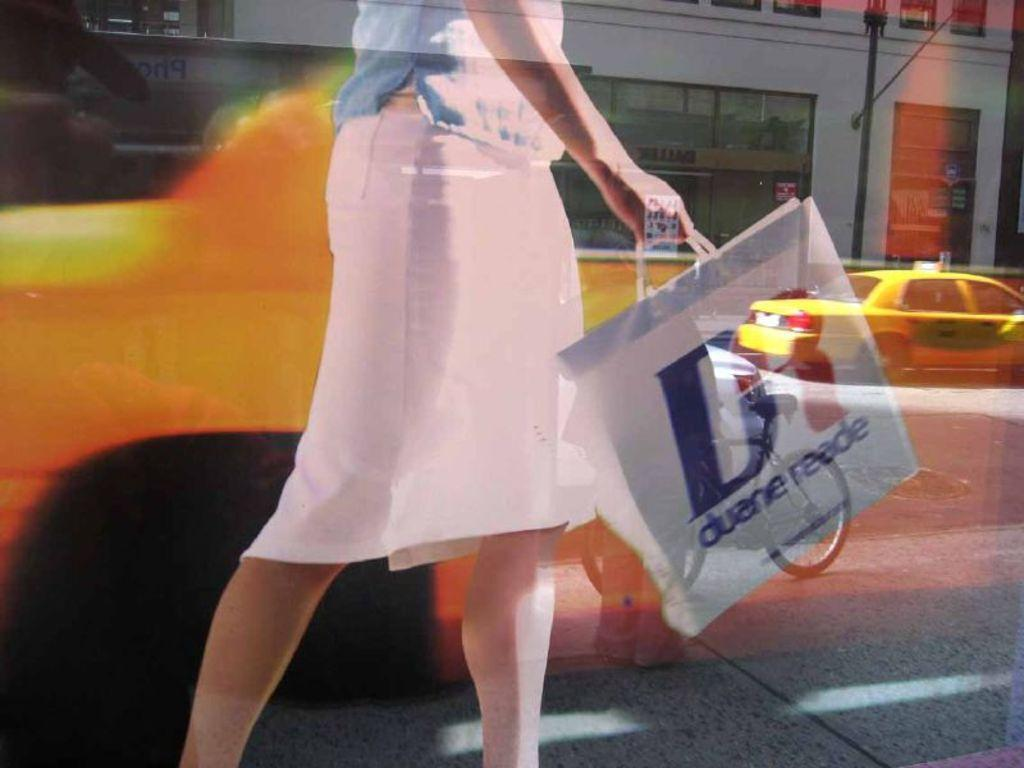Provide a one-sentence caption for the provided image. A woman in a pink skirt swinging a shopping bag from Duane Reade. 